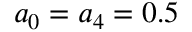Convert formula to latex. <formula><loc_0><loc_0><loc_500><loc_500>a _ { 0 } = a _ { 4 } = 0 . 5</formula> 